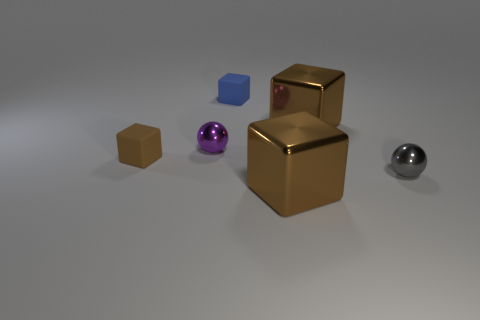Subtract all brown cubes. How many were subtracted if there are1brown cubes left? 2 Subtract all blue rubber cubes. How many cubes are left? 3 Add 3 small gray metallic balls. How many objects exist? 9 Subtract all purple balls. How many balls are left? 1 Subtract 1 cubes. How many cubes are left? 3 Subtract all purple balls. Subtract all purple cubes. How many balls are left? 1 Subtract all yellow balls. How many brown cubes are left? 3 Subtract all tiny gray metallic balls. Subtract all tiny rubber blocks. How many objects are left? 3 Add 5 big brown shiny things. How many big brown shiny things are left? 7 Add 3 metallic cylinders. How many metallic cylinders exist? 3 